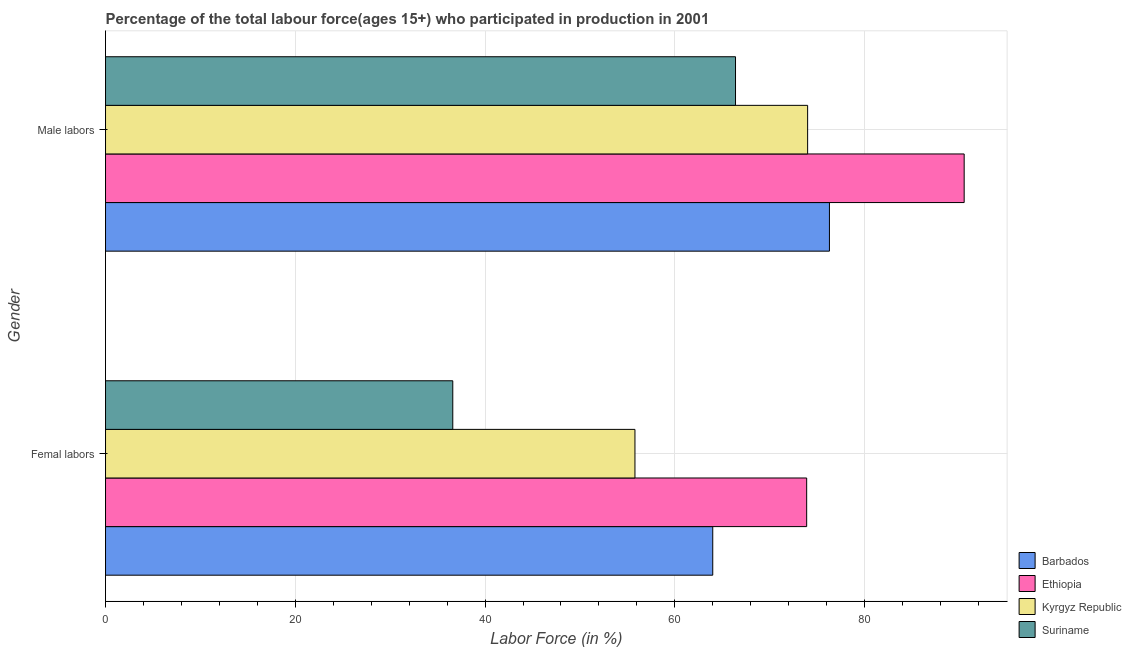How many groups of bars are there?
Ensure brevity in your answer.  2. What is the label of the 2nd group of bars from the top?
Offer a terse response. Femal labors. What is the percentage of male labour force in Ethiopia?
Offer a very short reply. 90.5. Across all countries, what is the maximum percentage of male labour force?
Your answer should be compact. 90.5. Across all countries, what is the minimum percentage of female labor force?
Provide a succinct answer. 36.6. In which country was the percentage of female labor force maximum?
Your response must be concise. Ethiopia. In which country was the percentage of male labour force minimum?
Keep it short and to the point. Suriname. What is the total percentage of female labor force in the graph?
Your answer should be compact. 230.3. What is the difference between the percentage of male labour force in Barbados and that in Ethiopia?
Offer a terse response. -14.2. What is the difference between the percentage of female labor force in Suriname and the percentage of male labour force in Barbados?
Your answer should be very brief. -39.7. What is the average percentage of female labor force per country?
Offer a very short reply. 57.57. What is the difference between the percentage of female labor force and percentage of male labour force in Ethiopia?
Your answer should be compact. -16.6. What is the ratio of the percentage of female labor force in Kyrgyz Republic to that in Barbados?
Your answer should be compact. 0.87. Is the percentage of female labor force in Kyrgyz Republic less than that in Barbados?
Provide a short and direct response. Yes. What does the 1st bar from the top in Femal labors represents?
Offer a very short reply. Suriname. What does the 2nd bar from the bottom in Male labors represents?
Offer a terse response. Ethiopia. Are all the bars in the graph horizontal?
Offer a very short reply. Yes. How many countries are there in the graph?
Make the answer very short. 4. Are the values on the major ticks of X-axis written in scientific E-notation?
Provide a succinct answer. No. Where does the legend appear in the graph?
Make the answer very short. Bottom right. How are the legend labels stacked?
Your answer should be very brief. Vertical. What is the title of the graph?
Make the answer very short. Percentage of the total labour force(ages 15+) who participated in production in 2001. What is the label or title of the Y-axis?
Keep it short and to the point. Gender. What is the Labor Force (in %) of Ethiopia in Femal labors?
Offer a terse response. 73.9. What is the Labor Force (in %) in Kyrgyz Republic in Femal labors?
Provide a succinct answer. 55.8. What is the Labor Force (in %) of Suriname in Femal labors?
Ensure brevity in your answer.  36.6. What is the Labor Force (in %) in Barbados in Male labors?
Keep it short and to the point. 76.3. What is the Labor Force (in %) of Ethiopia in Male labors?
Your answer should be very brief. 90.5. What is the Labor Force (in %) of Suriname in Male labors?
Make the answer very short. 66.4. Across all Gender, what is the maximum Labor Force (in %) of Barbados?
Your answer should be compact. 76.3. Across all Gender, what is the maximum Labor Force (in %) of Ethiopia?
Keep it short and to the point. 90.5. Across all Gender, what is the maximum Labor Force (in %) in Kyrgyz Republic?
Offer a very short reply. 74. Across all Gender, what is the maximum Labor Force (in %) in Suriname?
Your response must be concise. 66.4. Across all Gender, what is the minimum Labor Force (in %) of Barbados?
Offer a terse response. 64. Across all Gender, what is the minimum Labor Force (in %) of Ethiopia?
Provide a short and direct response. 73.9. Across all Gender, what is the minimum Labor Force (in %) in Kyrgyz Republic?
Your answer should be compact. 55.8. Across all Gender, what is the minimum Labor Force (in %) in Suriname?
Ensure brevity in your answer.  36.6. What is the total Labor Force (in %) of Barbados in the graph?
Make the answer very short. 140.3. What is the total Labor Force (in %) in Ethiopia in the graph?
Keep it short and to the point. 164.4. What is the total Labor Force (in %) of Kyrgyz Republic in the graph?
Your answer should be compact. 129.8. What is the total Labor Force (in %) of Suriname in the graph?
Your answer should be very brief. 103. What is the difference between the Labor Force (in %) in Ethiopia in Femal labors and that in Male labors?
Your answer should be very brief. -16.6. What is the difference between the Labor Force (in %) in Kyrgyz Republic in Femal labors and that in Male labors?
Make the answer very short. -18.2. What is the difference between the Labor Force (in %) in Suriname in Femal labors and that in Male labors?
Provide a succinct answer. -29.8. What is the difference between the Labor Force (in %) in Barbados in Femal labors and the Labor Force (in %) in Ethiopia in Male labors?
Give a very brief answer. -26.5. What is the difference between the Labor Force (in %) in Barbados in Femal labors and the Labor Force (in %) in Kyrgyz Republic in Male labors?
Offer a terse response. -10. What is the difference between the Labor Force (in %) in Barbados in Femal labors and the Labor Force (in %) in Suriname in Male labors?
Provide a succinct answer. -2.4. What is the difference between the Labor Force (in %) of Ethiopia in Femal labors and the Labor Force (in %) of Suriname in Male labors?
Keep it short and to the point. 7.5. What is the difference between the Labor Force (in %) in Kyrgyz Republic in Femal labors and the Labor Force (in %) in Suriname in Male labors?
Keep it short and to the point. -10.6. What is the average Labor Force (in %) in Barbados per Gender?
Ensure brevity in your answer.  70.15. What is the average Labor Force (in %) of Ethiopia per Gender?
Provide a short and direct response. 82.2. What is the average Labor Force (in %) of Kyrgyz Republic per Gender?
Give a very brief answer. 64.9. What is the average Labor Force (in %) of Suriname per Gender?
Keep it short and to the point. 51.5. What is the difference between the Labor Force (in %) in Barbados and Labor Force (in %) in Ethiopia in Femal labors?
Your answer should be very brief. -9.9. What is the difference between the Labor Force (in %) of Barbados and Labor Force (in %) of Kyrgyz Republic in Femal labors?
Offer a terse response. 8.2. What is the difference between the Labor Force (in %) of Barbados and Labor Force (in %) of Suriname in Femal labors?
Provide a succinct answer. 27.4. What is the difference between the Labor Force (in %) in Ethiopia and Labor Force (in %) in Kyrgyz Republic in Femal labors?
Keep it short and to the point. 18.1. What is the difference between the Labor Force (in %) of Ethiopia and Labor Force (in %) of Suriname in Femal labors?
Keep it short and to the point. 37.3. What is the difference between the Labor Force (in %) of Kyrgyz Republic and Labor Force (in %) of Suriname in Femal labors?
Provide a short and direct response. 19.2. What is the difference between the Labor Force (in %) in Barbados and Labor Force (in %) in Ethiopia in Male labors?
Your answer should be very brief. -14.2. What is the difference between the Labor Force (in %) of Barbados and Labor Force (in %) of Kyrgyz Republic in Male labors?
Provide a succinct answer. 2.3. What is the difference between the Labor Force (in %) of Ethiopia and Labor Force (in %) of Suriname in Male labors?
Offer a terse response. 24.1. What is the ratio of the Labor Force (in %) in Barbados in Femal labors to that in Male labors?
Offer a very short reply. 0.84. What is the ratio of the Labor Force (in %) in Ethiopia in Femal labors to that in Male labors?
Provide a short and direct response. 0.82. What is the ratio of the Labor Force (in %) of Kyrgyz Republic in Femal labors to that in Male labors?
Offer a very short reply. 0.75. What is the ratio of the Labor Force (in %) of Suriname in Femal labors to that in Male labors?
Give a very brief answer. 0.55. What is the difference between the highest and the second highest Labor Force (in %) of Ethiopia?
Offer a terse response. 16.6. What is the difference between the highest and the second highest Labor Force (in %) of Suriname?
Make the answer very short. 29.8. What is the difference between the highest and the lowest Labor Force (in %) in Barbados?
Your answer should be compact. 12.3. What is the difference between the highest and the lowest Labor Force (in %) of Suriname?
Make the answer very short. 29.8. 